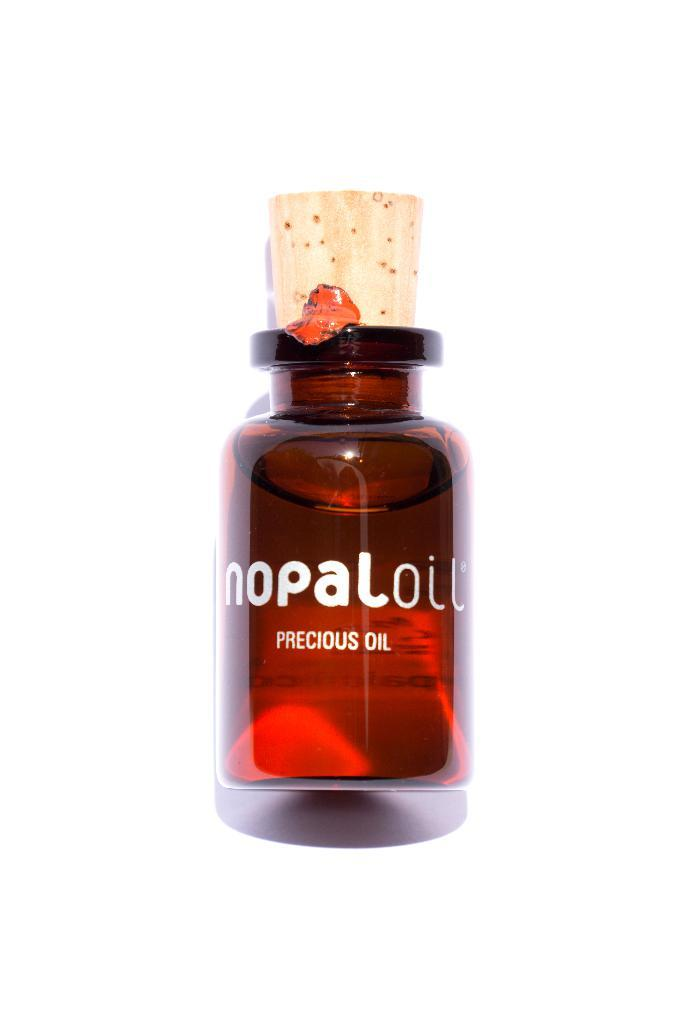<image>
Create a compact narrative representing the image presented. A bottle of Nopal oil with a cork in it. 